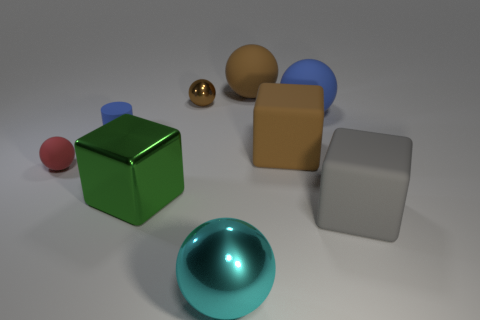Subtract 1 spheres. How many spheres are left? 4 Subtract all red balls. How many balls are left? 4 Subtract all large blue rubber balls. How many balls are left? 4 Subtract all purple spheres. Subtract all purple cubes. How many spheres are left? 5 Add 1 small brown things. How many objects exist? 10 Subtract all blocks. How many objects are left? 6 Add 7 brown objects. How many brown objects are left? 10 Add 7 cyan objects. How many cyan objects exist? 8 Subtract 1 gray blocks. How many objects are left? 8 Subtract all gray rubber objects. Subtract all red balls. How many objects are left? 7 